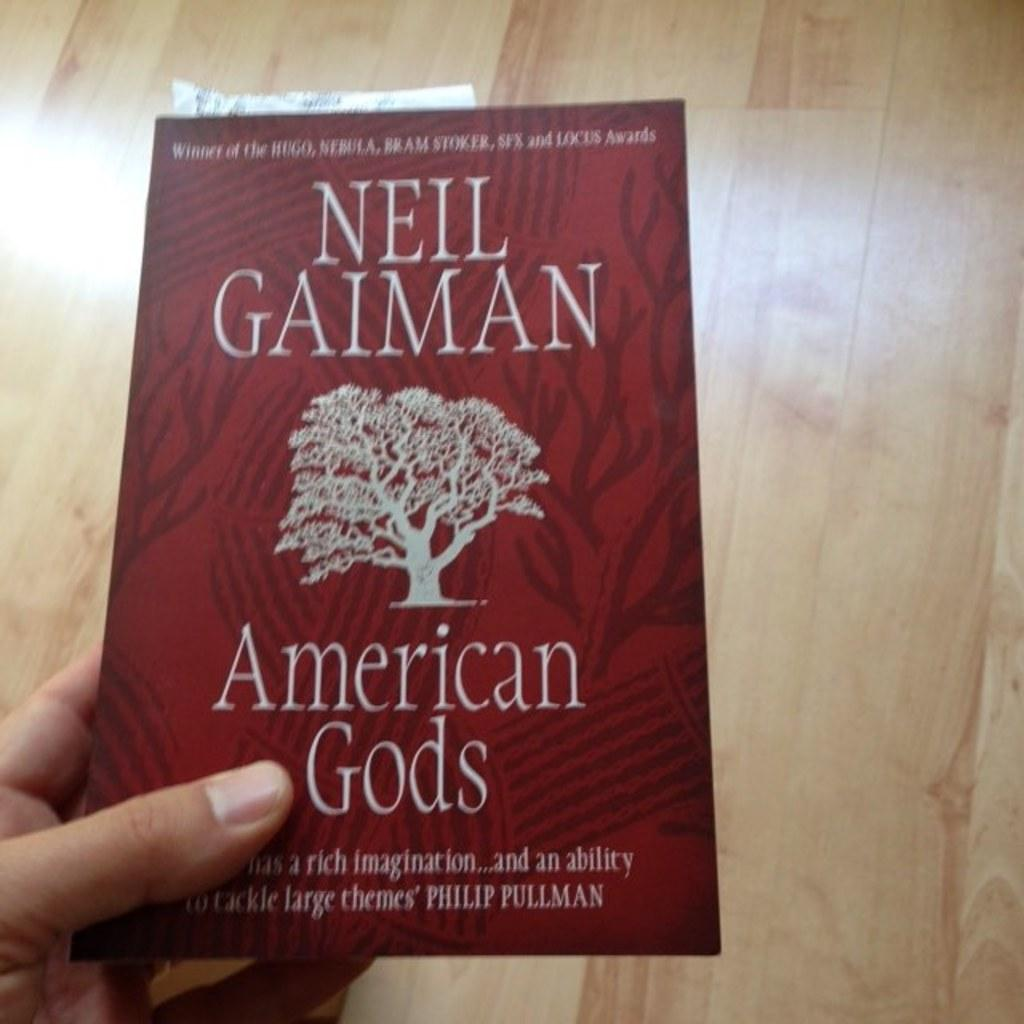<image>
Present a compact description of the photo's key features. Hand holding a small book by Neil Gaiman titled: American Gods. 